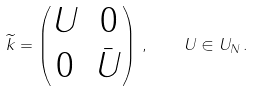Convert formula to latex. <formula><loc_0><loc_0><loc_500><loc_500>\widetilde { k } = \begin{pmatrix} U & 0 \\ 0 & \bar { U } \end{pmatrix} \, , \quad U \in U _ { N } \, .</formula> 